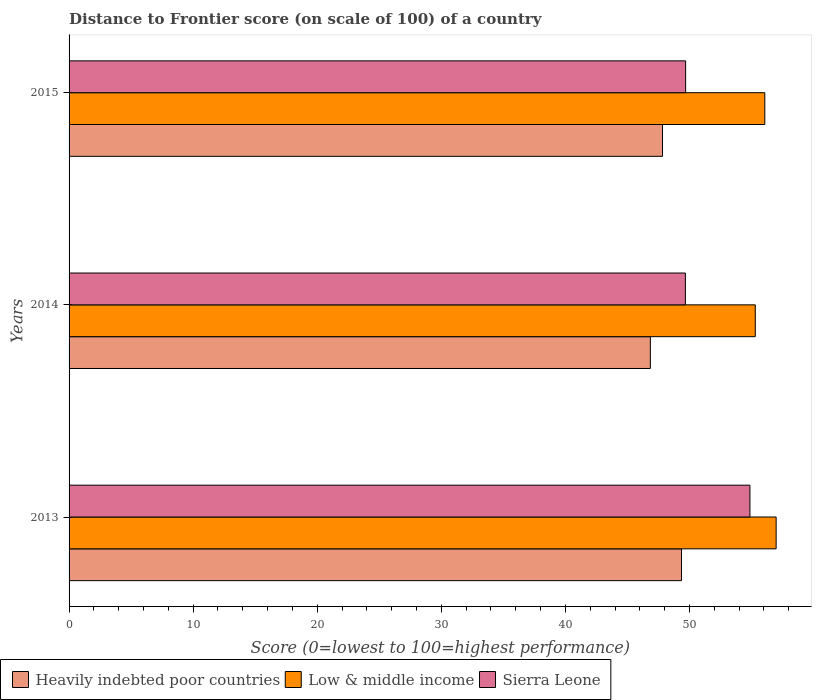How many different coloured bars are there?
Make the answer very short. 3. Are the number of bars per tick equal to the number of legend labels?
Ensure brevity in your answer.  Yes. Are the number of bars on each tick of the Y-axis equal?
Offer a terse response. Yes. In how many cases, is the number of bars for a given year not equal to the number of legend labels?
Give a very brief answer. 0. What is the distance to frontier score of in Sierra Leone in 2013?
Make the answer very short. 54.87. Across all years, what is the maximum distance to frontier score of in Heavily indebted poor countries?
Offer a very short reply. 49.36. Across all years, what is the minimum distance to frontier score of in Heavily indebted poor countries?
Offer a terse response. 46.85. In which year was the distance to frontier score of in Low & middle income maximum?
Provide a short and direct response. 2013. In which year was the distance to frontier score of in Heavily indebted poor countries minimum?
Give a very brief answer. 2014. What is the total distance to frontier score of in Heavily indebted poor countries in the graph?
Your answer should be very brief. 144.03. What is the difference between the distance to frontier score of in Heavily indebted poor countries in 2014 and that in 2015?
Provide a succinct answer. -0.98. What is the difference between the distance to frontier score of in Low & middle income in 2014 and the distance to frontier score of in Sierra Leone in 2015?
Your response must be concise. 5.61. What is the average distance to frontier score of in Low & middle income per year?
Give a very brief answer. 56.12. In the year 2013, what is the difference between the distance to frontier score of in Heavily indebted poor countries and distance to frontier score of in Sierra Leone?
Your response must be concise. -5.51. In how many years, is the distance to frontier score of in Sierra Leone greater than 12 ?
Offer a very short reply. 3. What is the ratio of the distance to frontier score of in Sierra Leone in 2013 to that in 2015?
Provide a short and direct response. 1.1. Is the distance to frontier score of in Heavily indebted poor countries in 2014 less than that in 2015?
Provide a succinct answer. Yes. Is the difference between the distance to frontier score of in Heavily indebted poor countries in 2013 and 2015 greater than the difference between the distance to frontier score of in Sierra Leone in 2013 and 2015?
Make the answer very short. No. What is the difference between the highest and the second highest distance to frontier score of in Heavily indebted poor countries?
Make the answer very short. 1.53. What is the difference between the highest and the lowest distance to frontier score of in Low & middle income?
Offer a very short reply. 1.68. In how many years, is the distance to frontier score of in Sierra Leone greater than the average distance to frontier score of in Sierra Leone taken over all years?
Your response must be concise. 1. Is the sum of the distance to frontier score of in Sierra Leone in 2013 and 2014 greater than the maximum distance to frontier score of in Low & middle income across all years?
Provide a succinct answer. Yes. What does the 3rd bar from the top in 2015 represents?
Ensure brevity in your answer.  Heavily indebted poor countries. What does the 3rd bar from the bottom in 2013 represents?
Your answer should be very brief. Sierra Leone. Is it the case that in every year, the sum of the distance to frontier score of in Heavily indebted poor countries and distance to frontier score of in Low & middle income is greater than the distance to frontier score of in Sierra Leone?
Your response must be concise. Yes. How many bars are there?
Offer a terse response. 9. Are all the bars in the graph horizontal?
Keep it short and to the point. Yes. How many years are there in the graph?
Give a very brief answer. 3. What is the difference between two consecutive major ticks on the X-axis?
Provide a succinct answer. 10. Are the values on the major ticks of X-axis written in scientific E-notation?
Ensure brevity in your answer.  No. Does the graph contain any zero values?
Keep it short and to the point. No. Where does the legend appear in the graph?
Offer a terse response. Bottom left. How many legend labels are there?
Make the answer very short. 3. What is the title of the graph?
Provide a short and direct response. Distance to Frontier score (on scale of 100) of a country. Does "Estonia" appear as one of the legend labels in the graph?
Offer a very short reply. No. What is the label or title of the X-axis?
Your response must be concise. Score (0=lowest to 100=highest performance). What is the Score (0=lowest to 100=highest performance) in Heavily indebted poor countries in 2013?
Keep it short and to the point. 49.36. What is the Score (0=lowest to 100=highest performance) in Low & middle income in 2013?
Provide a succinct answer. 56.98. What is the Score (0=lowest to 100=highest performance) in Sierra Leone in 2013?
Keep it short and to the point. 54.87. What is the Score (0=lowest to 100=highest performance) of Heavily indebted poor countries in 2014?
Your answer should be very brief. 46.85. What is the Score (0=lowest to 100=highest performance) of Low & middle income in 2014?
Your answer should be very brief. 55.3. What is the Score (0=lowest to 100=highest performance) of Sierra Leone in 2014?
Give a very brief answer. 49.67. What is the Score (0=lowest to 100=highest performance) in Heavily indebted poor countries in 2015?
Provide a short and direct response. 47.83. What is the Score (0=lowest to 100=highest performance) in Low & middle income in 2015?
Your answer should be very brief. 56.07. What is the Score (0=lowest to 100=highest performance) of Sierra Leone in 2015?
Your answer should be compact. 49.69. Across all years, what is the maximum Score (0=lowest to 100=highest performance) of Heavily indebted poor countries?
Give a very brief answer. 49.36. Across all years, what is the maximum Score (0=lowest to 100=highest performance) of Low & middle income?
Provide a short and direct response. 56.98. Across all years, what is the maximum Score (0=lowest to 100=highest performance) in Sierra Leone?
Offer a very short reply. 54.87. Across all years, what is the minimum Score (0=lowest to 100=highest performance) in Heavily indebted poor countries?
Your answer should be compact. 46.85. Across all years, what is the minimum Score (0=lowest to 100=highest performance) in Low & middle income?
Your answer should be compact. 55.3. Across all years, what is the minimum Score (0=lowest to 100=highest performance) in Sierra Leone?
Offer a terse response. 49.67. What is the total Score (0=lowest to 100=highest performance) of Heavily indebted poor countries in the graph?
Your answer should be compact. 144.03. What is the total Score (0=lowest to 100=highest performance) of Low & middle income in the graph?
Your answer should be compact. 168.35. What is the total Score (0=lowest to 100=highest performance) of Sierra Leone in the graph?
Make the answer very short. 154.23. What is the difference between the Score (0=lowest to 100=highest performance) in Heavily indebted poor countries in 2013 and that in 2014?
Offer a very short reply. 2.51. What is the difference between the Score (0=lowest to 100=highest performance) in Low & middle income in 2013 and that in 2014?
Keep it short and to the point. 1.68. What is the difference between the Score (0=lowest to 100=highest performance) of Sierra Leone in 2013 and that in 2014?
Ensure brevity in your answer.  5.2. What is the difference between the Score (0=lowest to 100=highest performance) of Heavily indebted poor countries in 2013 and that in 2015?
Offer a terse response. 1.53. What is the difference between the Score (0=lowest to 100=highest performance) of Low & middle income in 2013 and that in 2015?
Offer a very short reply. 0.91. What is the difference between the Score (0=lowest to 100=highest performance) of Sierra Leone in 2013 and that in 2015?
Keep it short and to the point. 5.18. What is the difference between the Score (0=lowest to 100=highest performance) in Heavily indebted poor countries in 2014 and that in 2015?
Provide a succinct answer. -0.98. What is the difference between the Score (0=lowest to 100=highest performance) of Low & middle income in 2014 and that in 2015?
Offer a terse response. -0.77. What is the difference between the Score (0=lowest to 100=highest performance) in Sierra Leone in 2014 and that in 2015?
Ensure brevity in your answer.  -0.02. What is the difference between the Score (0=lowest to 100=highest performance) of Heavily indebted poor countries in 2013 and the Score (0=lowest to 100=highest performance) of Low & middle income in 2014?
Your answer should be compact. -5.94. What is the difference between the Score (0=lowest to 100=highest performance) of Heavily indebted poor countries in 2013 and the Score (0=lowest to 100=highest performance) of Sierra Leone in 2014?
Offer a terse response. -0.31. What is the difference between the Score (0=lowest to 100=highest performance) of Low & middle income in 2013 and the Score (0=lowest to 100=highest performance) of Sierra Leone in 2014?
Offer a terse response. 7.31. What is the difference between the Score (0=lowest to 100=highest performance) of Heavily indebted poor countries in 2013 and the Score (0=lowest to 100=highest performance) of Low & middle income in 2015?
Provide a short and direct response. -6.71. What is the difference between the Score (0=lowest to 100=highest performance) of Heavily indebted poor countries in 2013 and the Score (0=lowest to 100=highest performance) of Sierra Leone in 2015?
Offer a terse response. -0.33. What is the difference between the Score (0=lowest to 100=highest performance) in Low & middle income in 2013 and the Score (0=lowest to 100=highest performance) in Sierra Leone in 2015?
Your response must be concise. 7.29. What is the difference between the Score (0=lowest to 100=highest performance) of Heavily indebted poor countries in 2014 and the Score (0=lowest to 100=highest performance) of Low & middle income in 2015?
Ensure brevity in your answer.  -9.22. What is the difference between the Score (0=lowest to 100=highest performance) in Heavily indebted poor countries in 2014 and the Score (0=lowest to 100=highest performance) in Sierra Leone in 2015?
Offer a terse response. -2.84. What is the difference between the Score (0=lowest to 100=highest performance) in Low & middle income in 2014 and the Score (0=lowest to 100=highest performance) in Sierra Leone in 2015?
Offer a terse response. 5.61. What is the average Score (0=lowest to 100=highest performance) in Heavily indebted poor countries per year?
Keep it short and to the point. 48.01. What is the average Score (0=lowest to 100=highest performance) of Low & middle income per year?
Offer a terse response. 56.12. What is the average Score (0=lowest to 100=highest performance) in Sierra Leone per year?
Keep it short and to the point. 51.41. In the year 2013, what is the difference between the Score (0=lowest to 100=highest performance) in Heavily indebted poor countries and Score (0=lowest to 100=highest performance) in Low & middle income?
Give a very brief answer. -7.63. In the year 2013, what is the difference between the Score (0=lowest to 100=highest performance) in Heavily indebted poor countries and Score (0=lowest to 100=highest performance) in Sierra Leone?
Your answer should be very brief. -5.51. In the year 2013, what is the difference between the Score (0=lowest to 100=highest performance) of Low & middle income and Score (0=lowest to 100=highest performance) of Sierra Leone?
Ensure brevity in your answer.  2.11. In the year 2014, what is the difference between the Score (0=lowest to 100=highest performance) of Heavily indebted poor countries and Score (0=lowest to 100=highest performance) of Low & middle income?
Make the answer very short. -8.46. In the year 2014, what is the difference between the Score (0=lowest to 100=highest performance) of Heavily indebted poor countries and Score (0=lowest to 100=highest performance) of Sierra Leone?
Keep it short and to the point. -2.82. In the year 2014, what is the difference between the Score (0=lowest to 100=highest performance) in Low & middle income and Score (0=lowest to 100=highest performance) in Sierra Leone?
Make the answer very short. 5.63. In the year 2015, what is the difference between the Score (0=lowest to 100=highest performance) of Heavily indebted poor countries and Score (0=lowest to 100=highest performance) of Low & middle income?
Give a very brief answer. -8.24. In the year 2015, what is the difference between the Score (0=lowest to 100=highest performance) in Heavily indebted poor countries and Score (0=lowest to 100=highest performance) in Sierra Leone?
Your answer should be very brief. -1.86. In the year 2015, what is the difference between the Score (0=lowest to 100=highest performance) of Low & middle income and Score (0=lowest to 100=highest performance) of Sierra Leone?
Provide a short and direct response. 6.38. What is the ratio of the Score (0=lowest to 100=highest performance) in Heavily indebted poor countries in 2013 to that in 2014?
Offer a very short reply. 1.05. What is the ratio of the Score (0=lowest to 100=highest performance) of Low & middle income in 2013 to that in 2014?
Ensure brevity in your answer.  1.03. What is the ratio of the Score (0=lowest to 100=highest performance) in Sierra Leone in 2013 to that in 2014?
Your answer should be compact. 1.1. What is the ratio of the Score (0=lowest to 100=highest performance) in Heavily indebted poor countries in 2013 to that in 2015?
Ensure brevity in your answer.  1.03. What is the ratio of the Score (0=lowest to 100=highest performance) in Low & middle income in 2013 to that in 2015?
Give a very brief answer. 1.02. What is the ratio of the Score (0=lowest to 100=highest performance) in Sierra Leone in 2013 to that in 2015?
Your response must be concise. 1.1. What is the ratio of the Score (0=lowest to 100=highest performance) of Heavily indebted poor countries in 2014 to that in 2015?
Provide a short and direct response. 0.98. What is the ratio of the Score (0=lowest to 100=highest performance) in Low & middle income in 2014 to that in 2015?
Give a very brief answer. 0.99. What is the ratio of the Score (0=lowest to 100=highest performance) in Sierra Leone in 2014 to that in 2015?
Make the answer very short. 1. What is the difference between the highest and the second highest Score (0=lowest to 100=highest performance) of Heavily indebted poor countries?
Ensure brevity in your answer.  1.53. What is the difference between the highest and the second highest Score (0=lowest to 100=highest performance) in Low & middle income?
Ensure brevity in your answer.  0.91. What is the difference between the highest and the second highest Score (0=lowest to 100=highest performance) of Sierra Leone?
Provide a succinct answer. 5.18. What is the difference between the highest and the lowest Score (0=lowest to 100=highest performance) in Heavily indebted poor countries?
Your answer should be very brief. 2.51. What is the difference between the highest and the lowest Score (0=lowest to 100=highest performance) in Low & middle income?
Keep it short and to the point. 1.68. What is the difference between the highest and the lowest Score (0=lowest to 100=highest performance) of Sierra Leone?
Give a very brief answer. 5.2. 